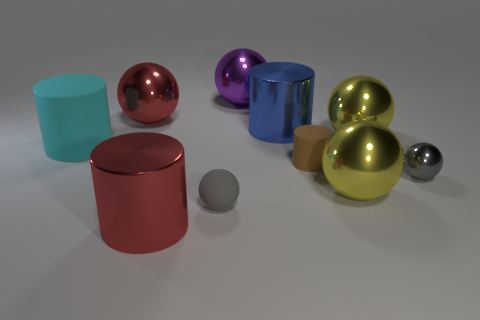Subtract all tiny matte balls. How many balls are left? 5 Subtract all red balls. How many balls are left? 5 Subtract all balls. How many objects are left? 4 Subtract all tiny gray rubber things. Subtract all big matte cylinders. How many objects are left? 8 Add 6 purple things. How many purple things are left? 7 Add 3 large cyan objects. How many large cyan objects exist? 4 Subtract 0 green cylinders. How many objects are left? 10 Subtract 4 cylinders. How many cylinders are left? 0 Subtract all green cylinders. Subtract all green cubes. How many cylinders are left? 4 Subtract all blue blocks. How many blue spheres are left? 0 